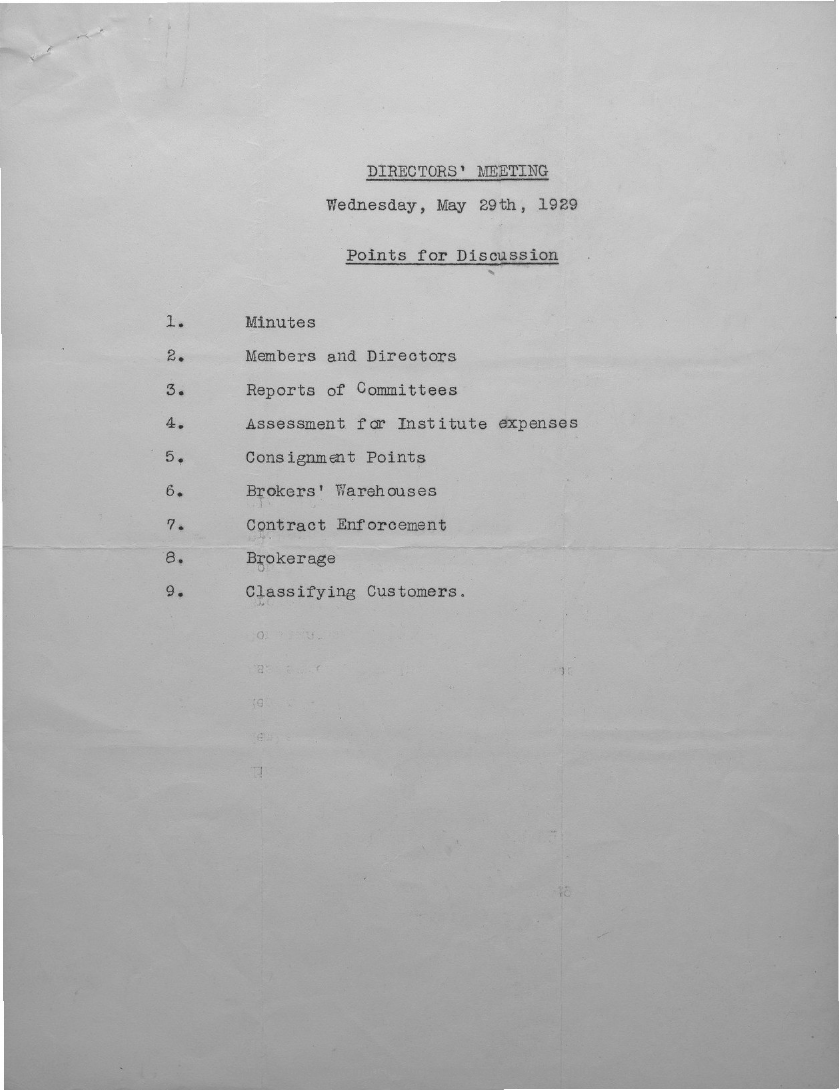Draw attention to some important aspects in this diagram. The directors' meeting will be held on Wednesday, May 29th, 1929. 